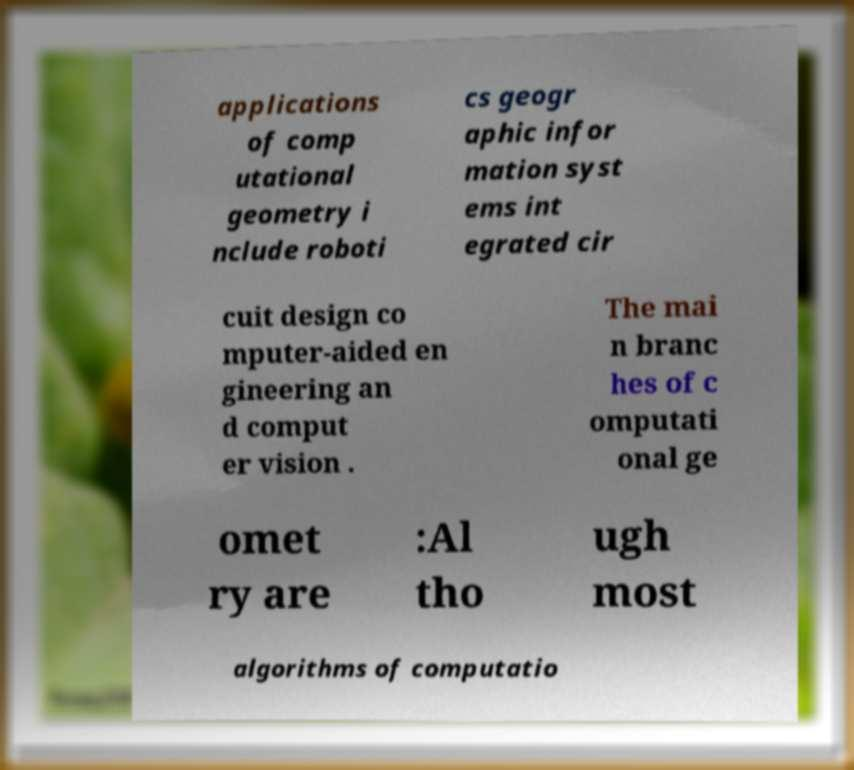Please identify and transcribe the text found in this image. applications of comp utational geometry i nclude roboti cs geogr aphic infor mation syst ems int egrated cir cuit design co mputer-aided en gineering an d comput er vision . The mai n branc hes of c omputati onal ge omet ry are :Al tho ugh most algorithms of computatio 